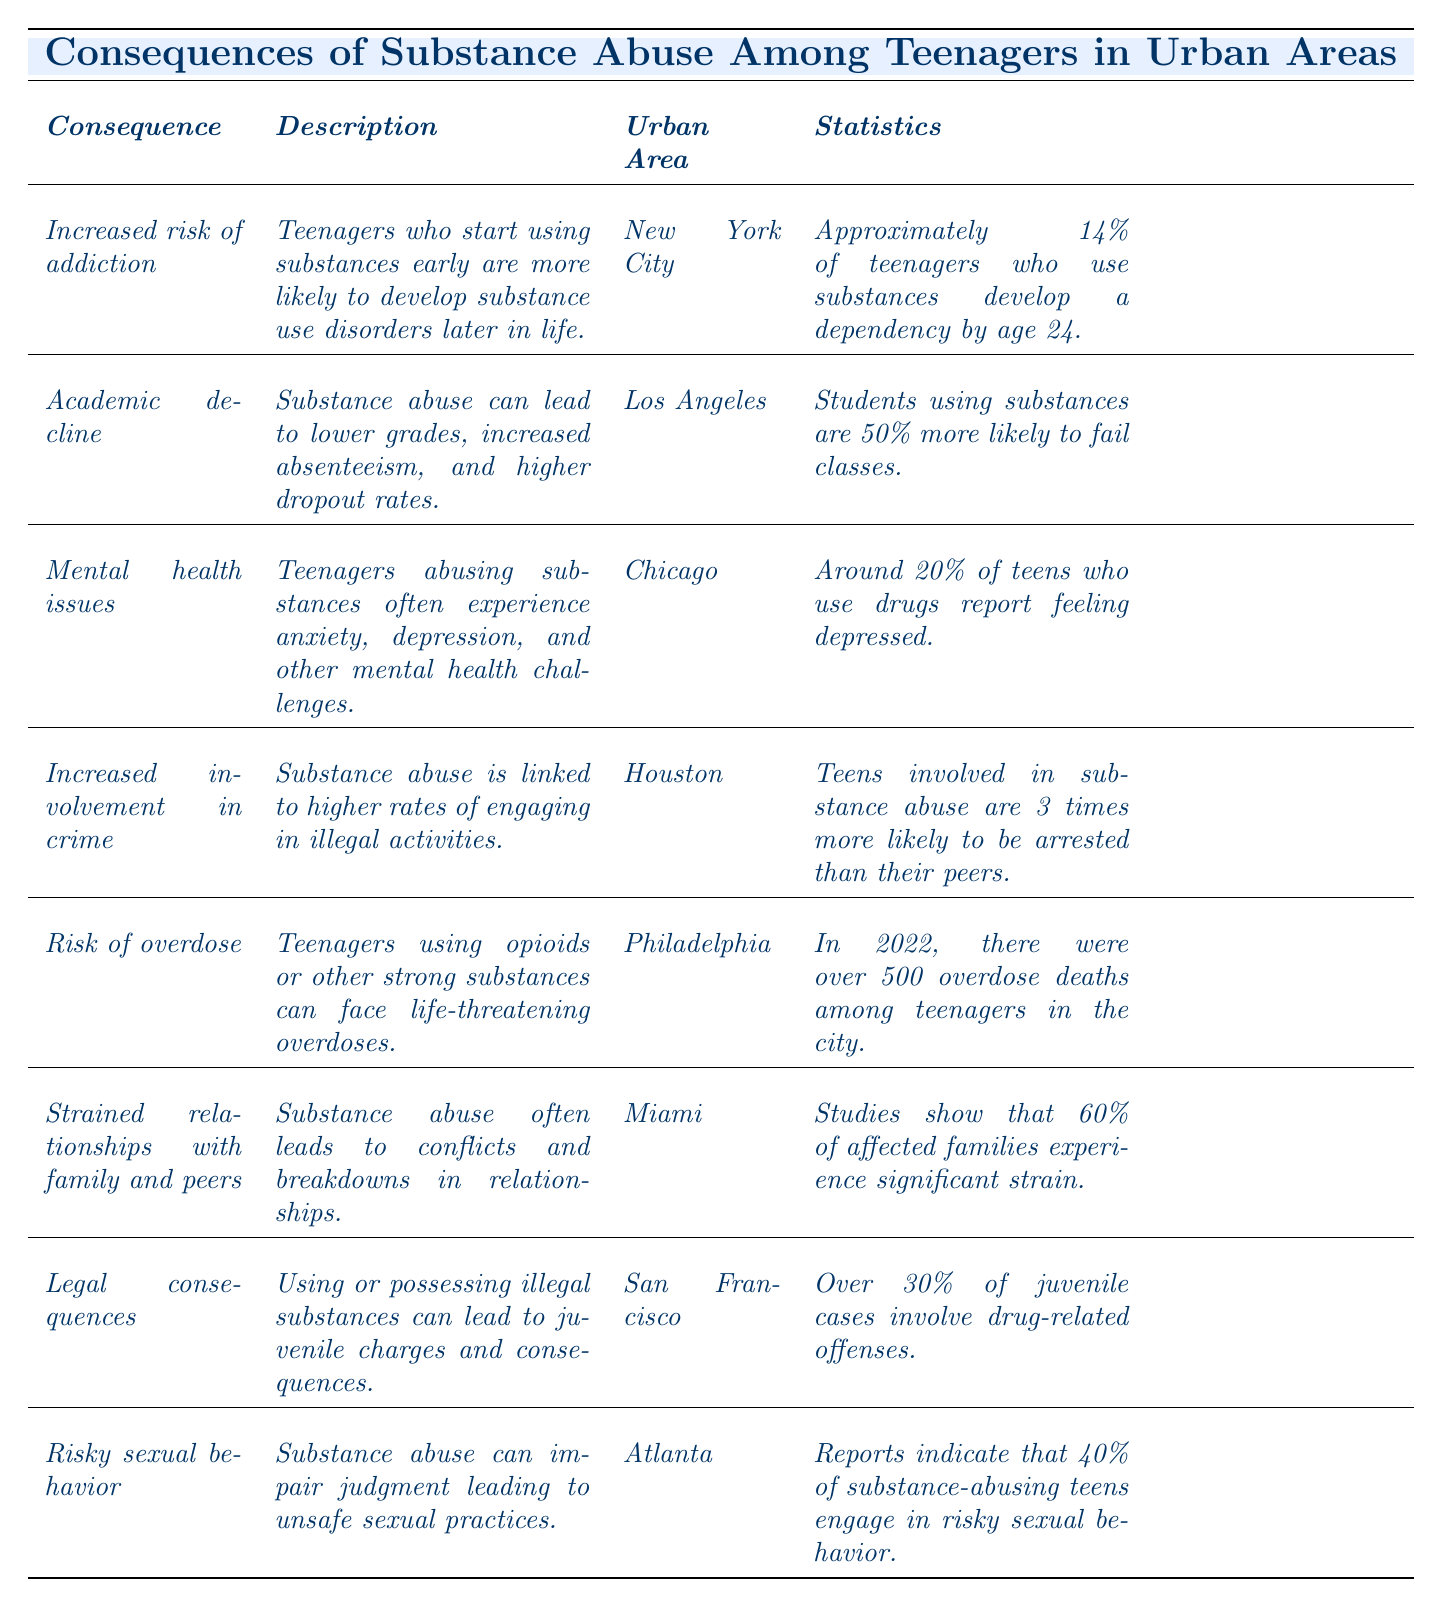What is the consequence associated with increased risk of addiction? The table indicates that the consequence related to increased risk of addiction is that teenagers who start using substances early are more likely to develop substance use disorders later in life.
Answer: Increased risk of addiction Which urban area is linked to academic decline? According to the table, academic decline is linked to Los Angeles, as that is the urban area listed in conjunction with this consequence.
Answer: Los Angeles How many times more likely are teens involved in substance abuse to be arrested compared to their peers? The table states that teens involved in substance abuse are 3 times more likely to be arrested than their peers when examining the increased involvement in crime.
Answer: 3 times What percentage of substance-abusing teens report feeling depressed? The table shows that around 20% of teens who use drugs report feeling depressed, as indicated under mental health issues.
Answer: 20% Which consequence has the highest percentage of affected families experiencing significant strain? The consequence with the highest percentage is strained relationships with family and peers, where 60% of affected families experience significant strain, according to the data provided.
Answer: 60% Is there a specific urban area associated with the risk of overdose? Yes, the urban area associated with the risk of overdose is Philadelphia, as stated in the table.
Answer: Yes What is the average percentage of involvement in drug-related offenses across the urban areas listed? The table indicates that there are percentages of 30% (San Francisco) related to legal consequences and various others, but only one specific percentage is mentioned for legal consequences. However, to answer correctly, we acknowledge the percentages of specific offenses rather than an average, as each statistic pertains to different consequences.
Answer: Not calculable Does any consequence directly mention the impact on education? Yes, academic decline directly mentions the impact on education by stating that substance abuse can lead to lower grades, increased absenteeism, and higher dropout rates.
Answer: Yes What are the two urban areas associated with the consequences of risky sexual behavior and mental health issues? The urban area associated with risky sexual behavior is Atlanta, while the urban area tied to mental health issues is Chicago, as displayed in the table.
Answer: Atlanta and Chicago How does the consequence of substance abuse relate to family dynamics? The table indicates that substance abuse often leads to conflicts and breakdowns in relationships, which is categorized under strained relationships with family and peers.
Answer: Conflicts and breakdowns in relationships 